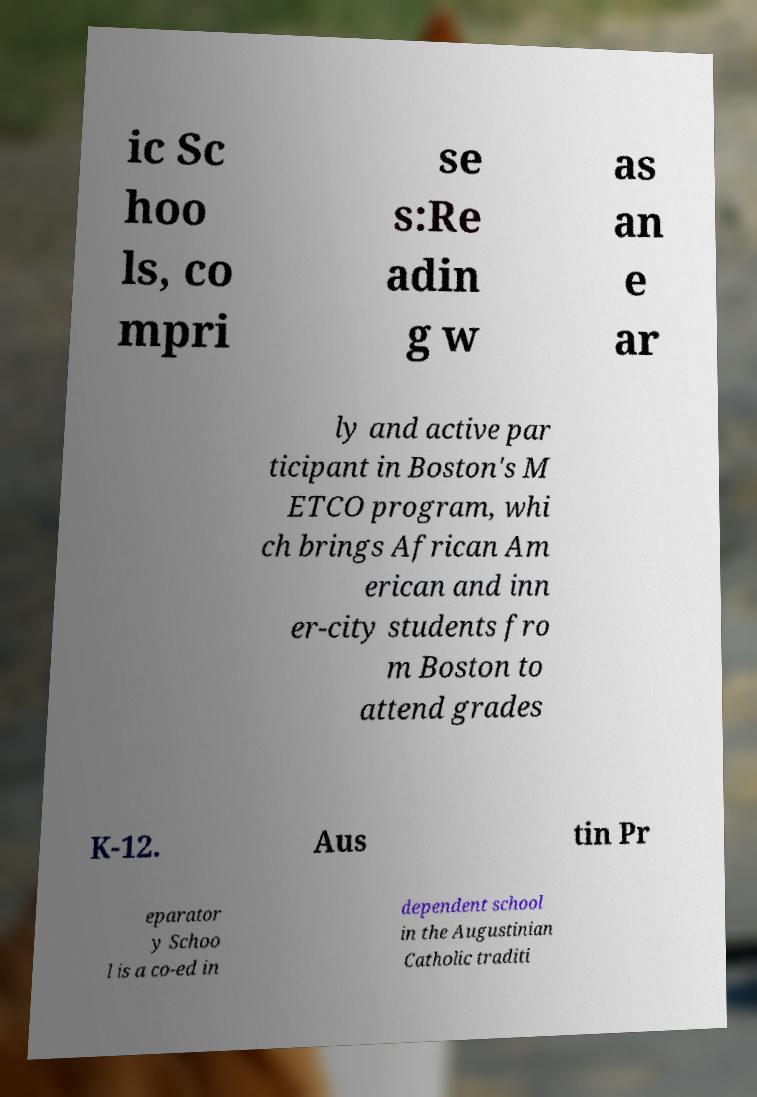Could you assist in decoding the text presented in this image and type it out clearly? ic Sc hoo ls, co mpri se s:Re adin g w as an e ar ly and active par ticipant in Boston's M ETCO program, whi ch brings African Am erican and inn er-city students fro m Boston to attend grades K-12. Aus tin Pr eparator y Schoo l is a co-ed in dependent school in the Augustinian Catholic traditi 